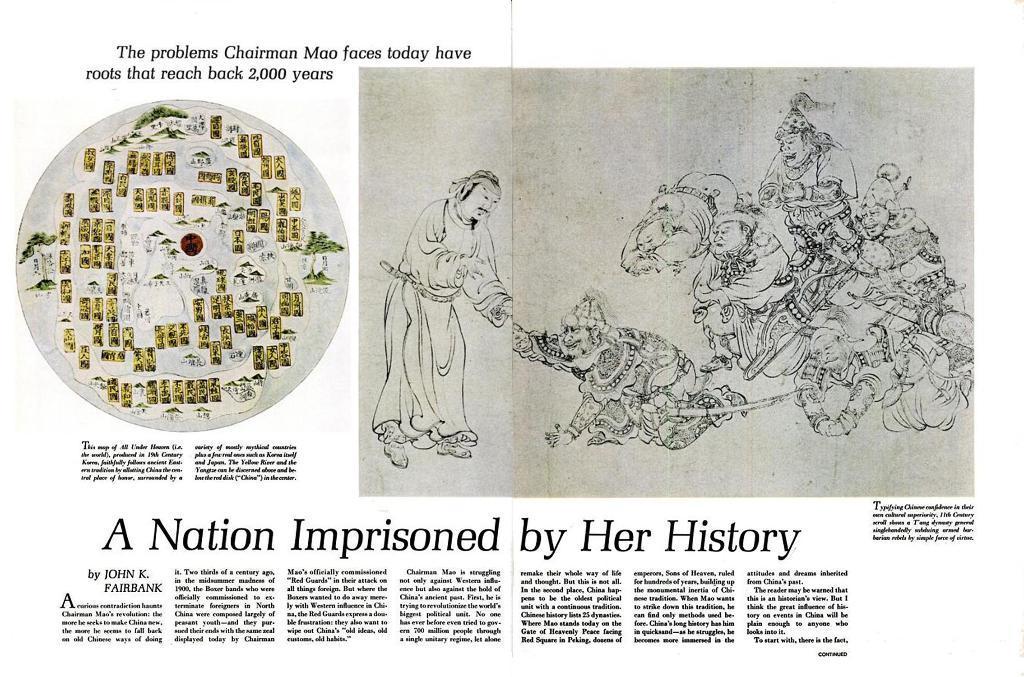Describe this image in one or two sentences. In this picture we can see a paper, in the paper we can find some text and pictures of few people. 